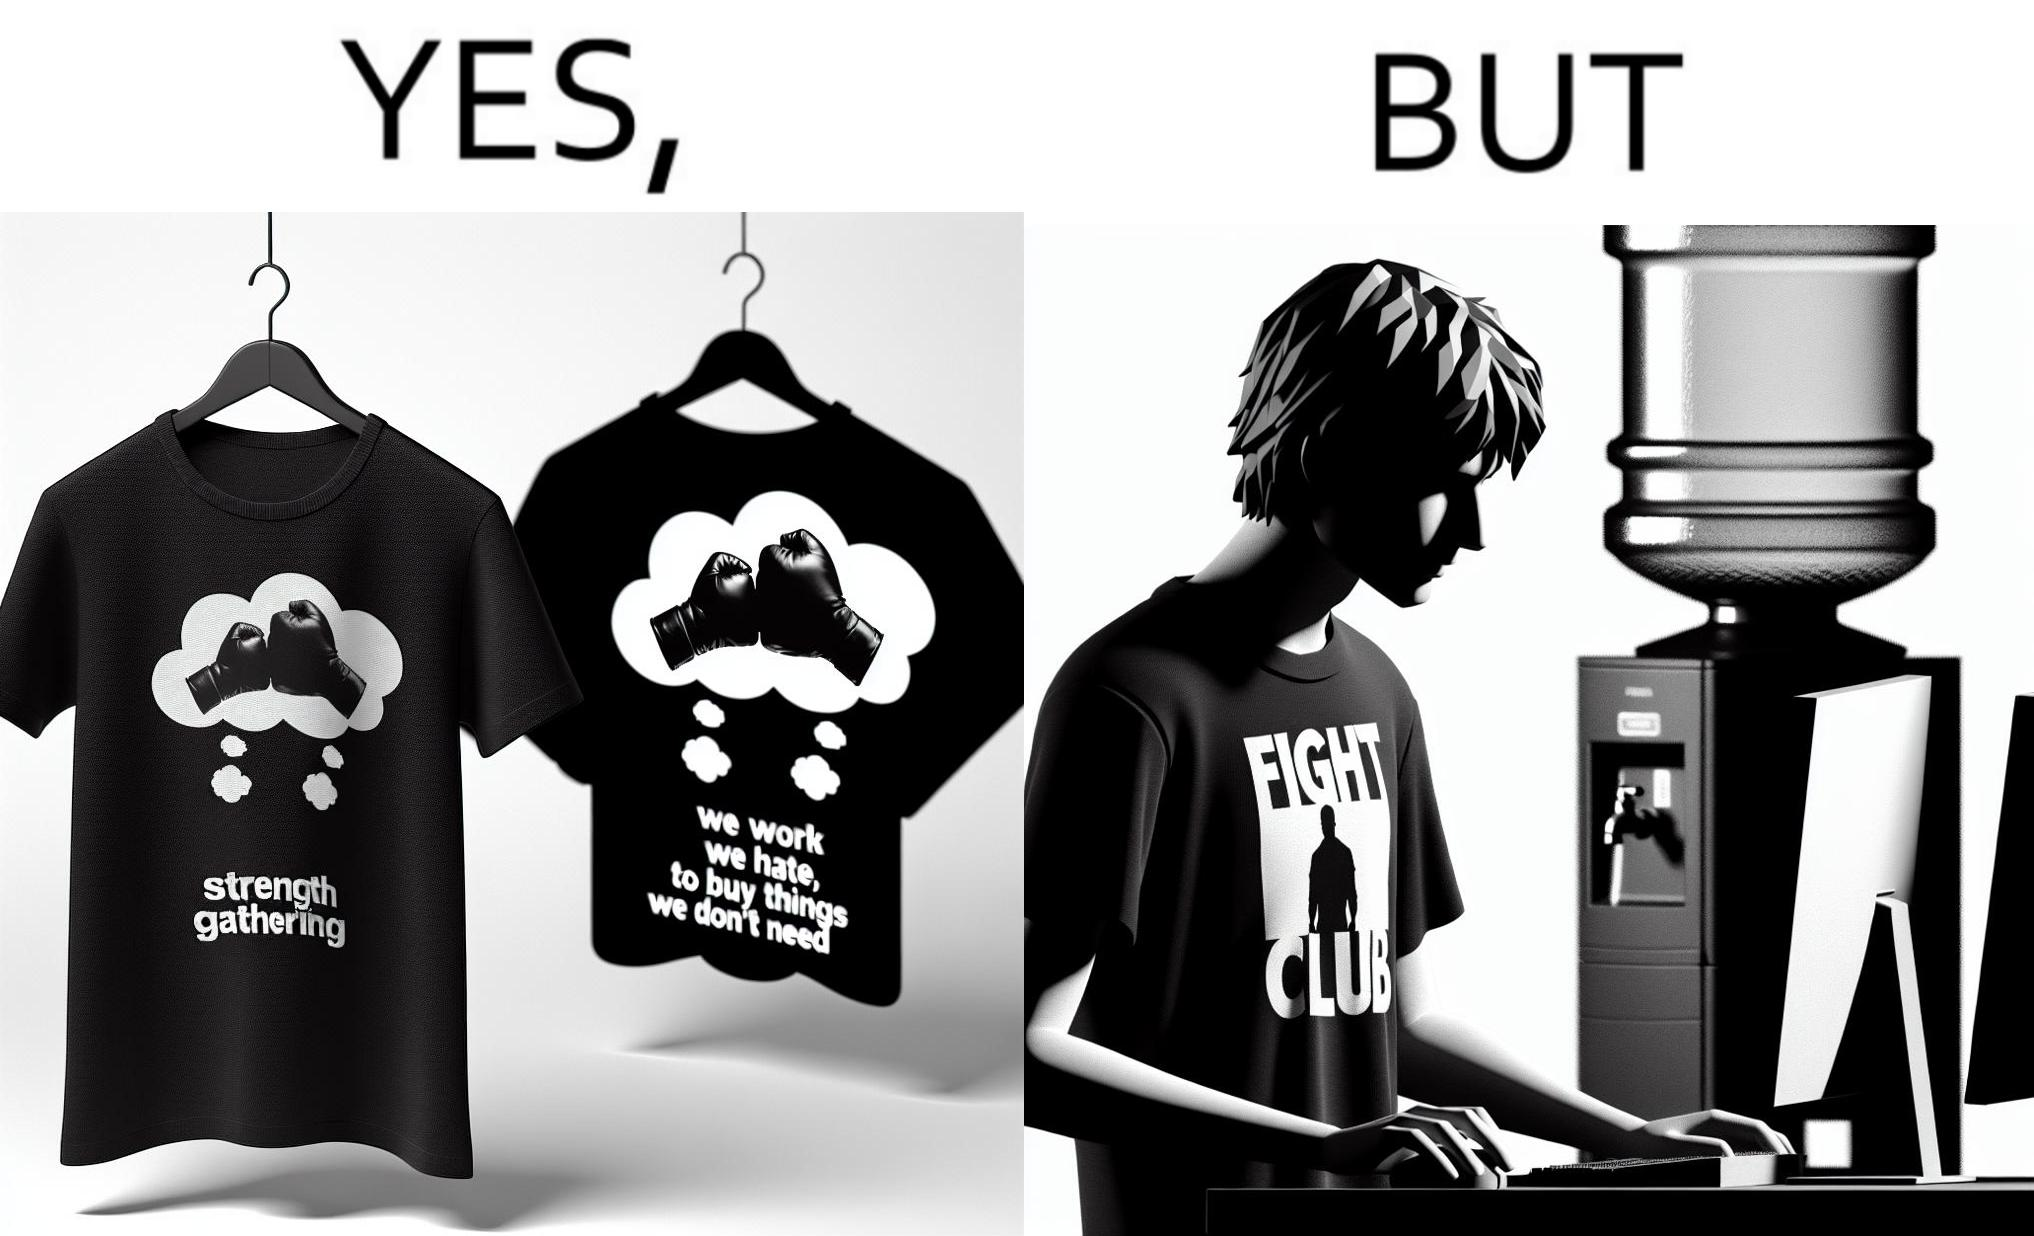What is shown in the left half versus the right half of this image? In the left part of the image: a t-shirt with "Fight Club" written on it (referring to the movie), along with a dialogue from the movie that says "We work jobs we hate, to buy sh*t we don't need". In the right part of the image: a person wearing a t-shirt that says "Fight Club", working on a computer system, with a water dispenser by the side. 